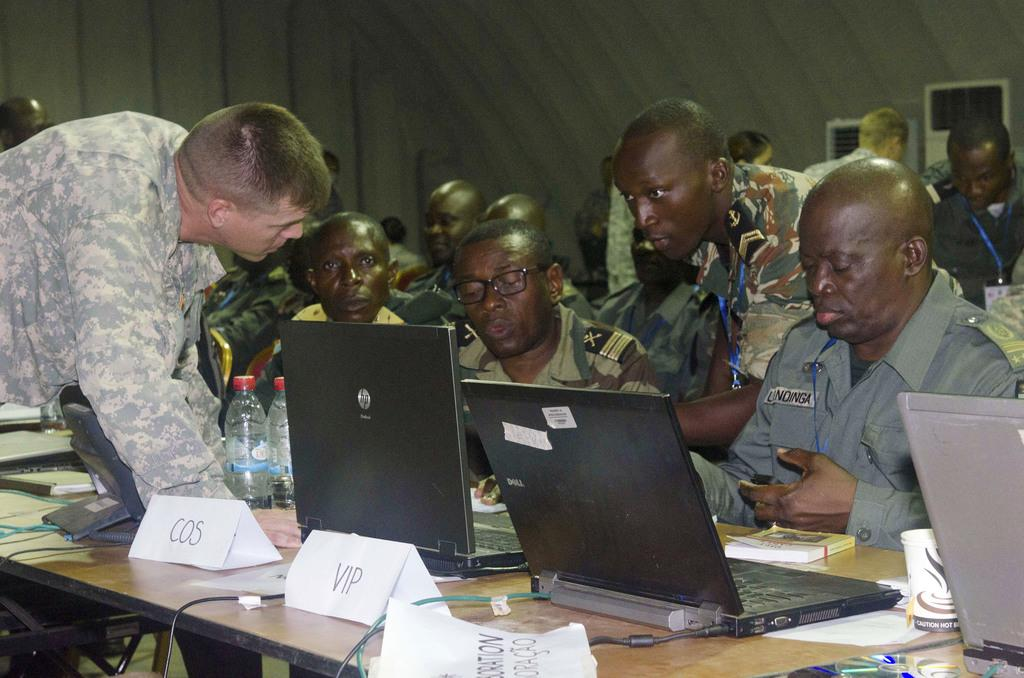Who or what can be seen in the image? There are people in the image. What electronic devices are visible in the image? There are laptops in the image. What items related to beverages can be seen in the image? There are bottles in the image. What items related to work or documentation can be seen in the image? There are files and papers in the image. What storage media can be seen in the image? There are compact discs in the image. What can be seen in the background of the image? There are white objects in the background of the image. Can you tell me how many dogs are present in the image? There are no dogs present in the image. What type of porter is responsible for carrying the files in the image? There is no porter present in the image, nor is there any indication that the files are being carried by someone. 